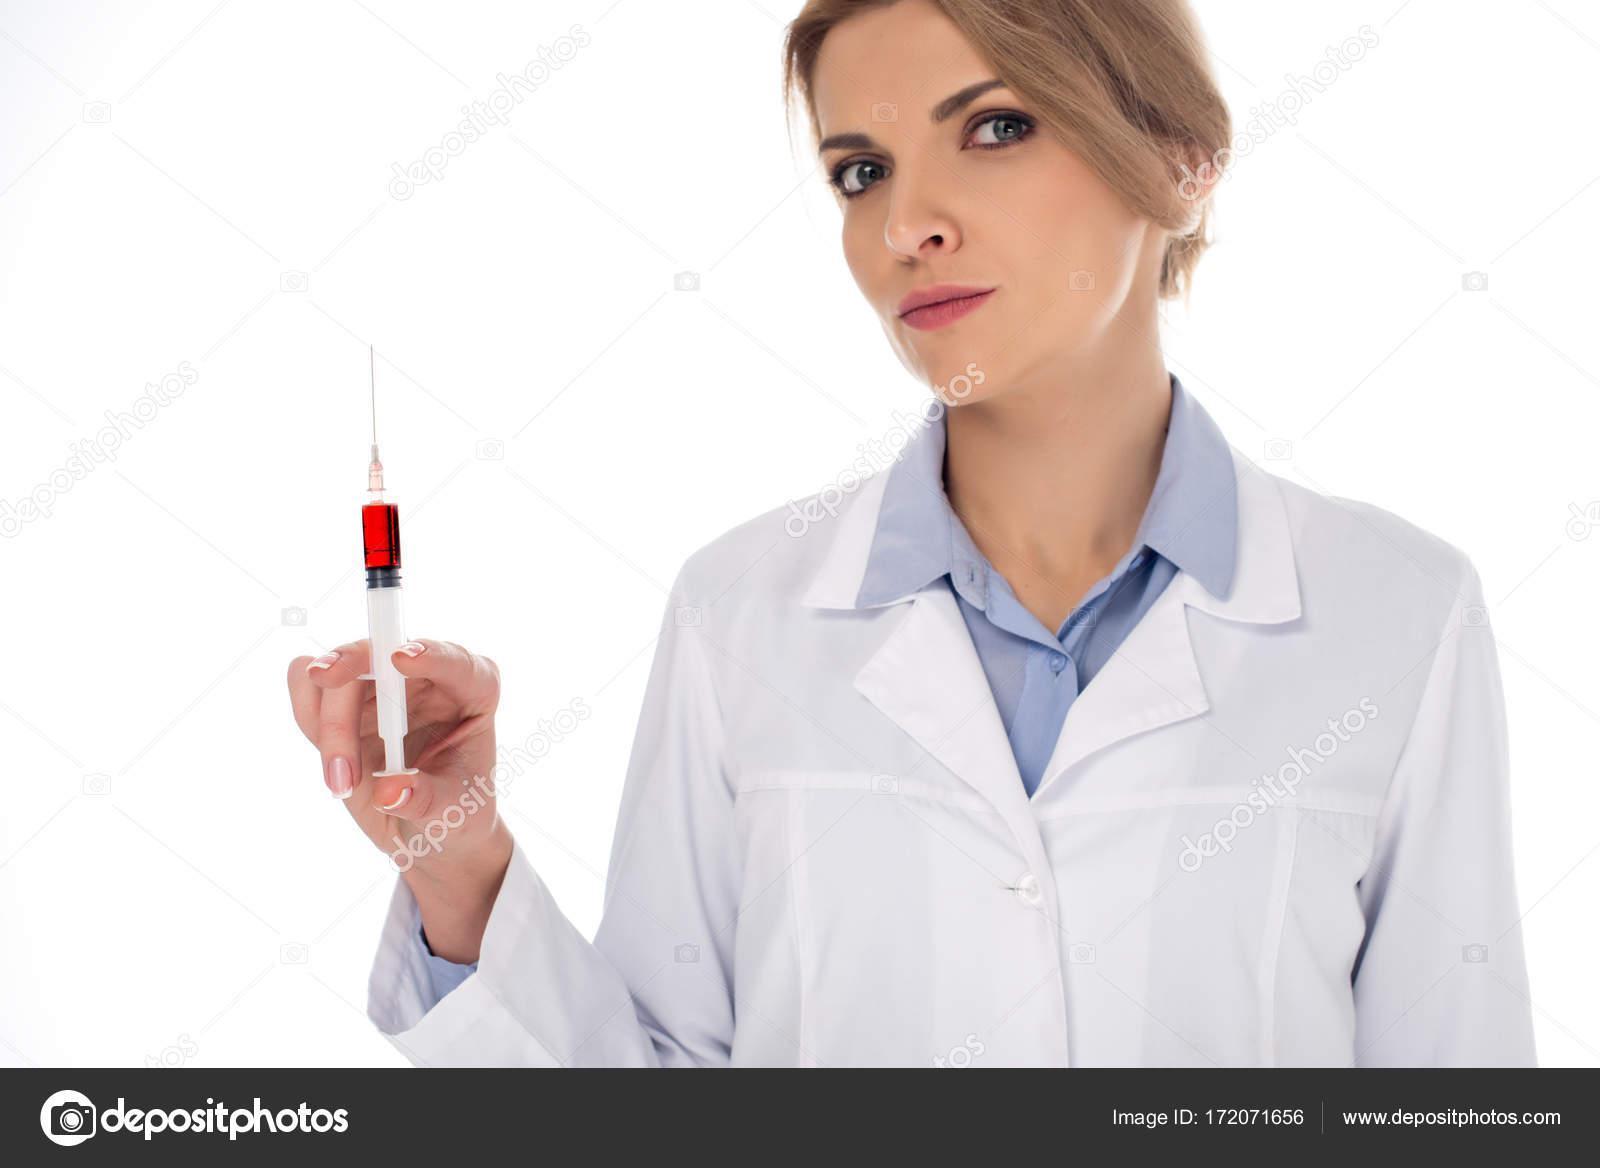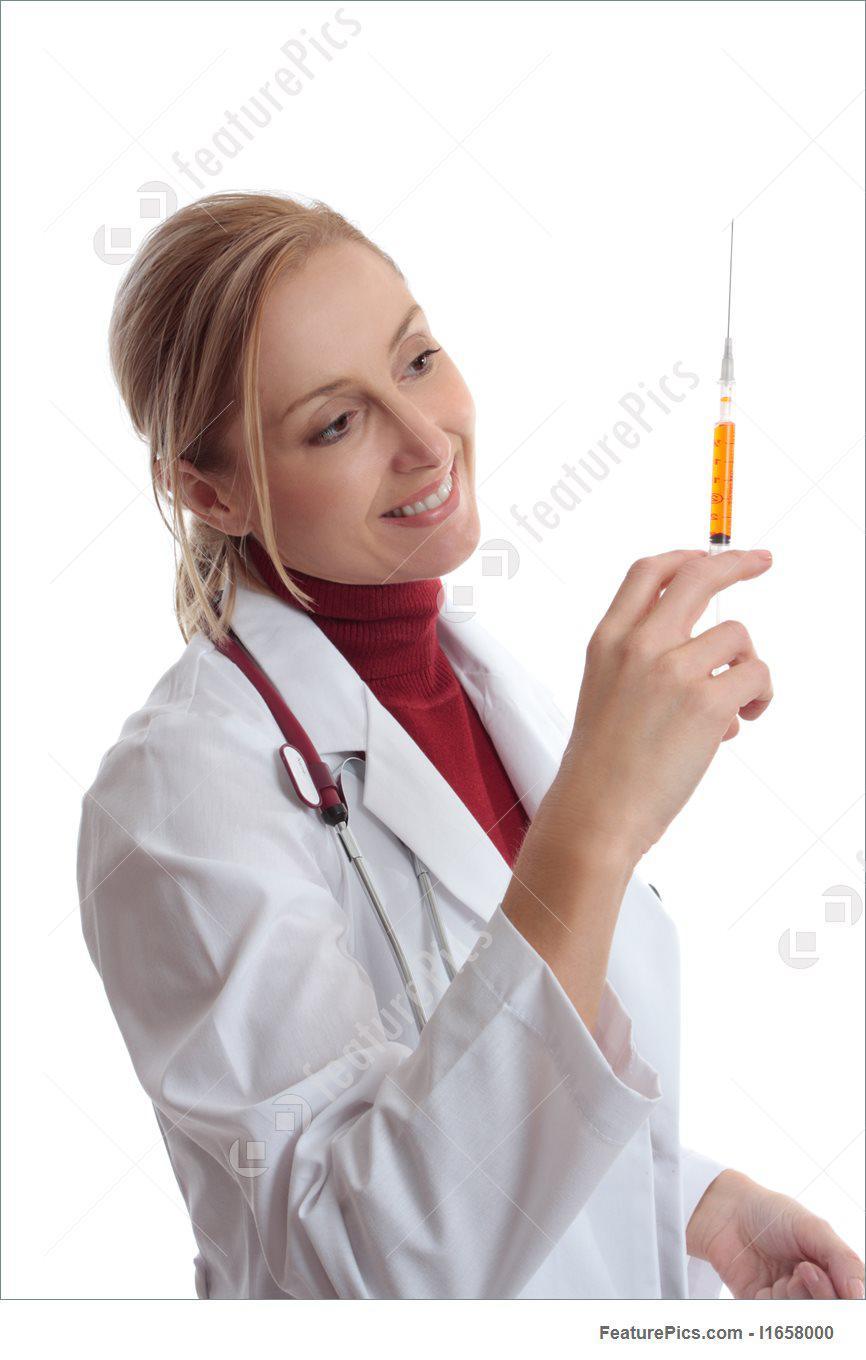The first image is the image on the left, the second image is the image on the right. Examine the images to the left and right. Is the description "The right image shows a forward-facing woman with a bare neck and white shirt holding up a syringe of yellow liquid." accurate? Answer yes or no. No. The first image is the image on the left, the second image is the image on the right. Analyze the images presented: Is the assertion "The left and right image contains a total of two woman holding needles." valid? Answer yes or no. Yes. 